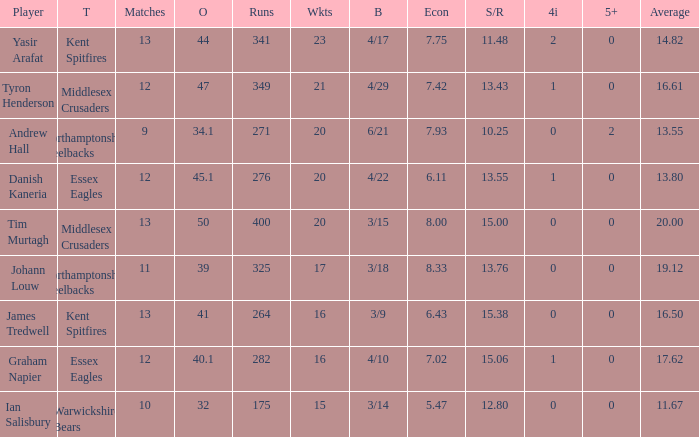Name the least matches for runs being 276 12.0. 